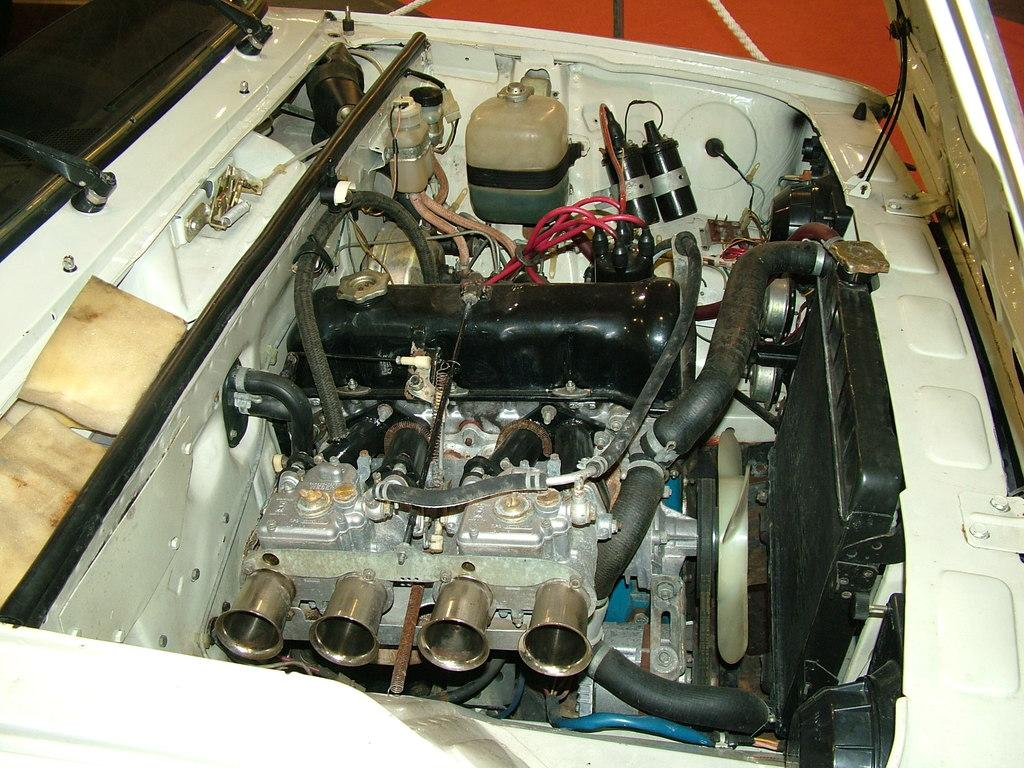What is the main subject of the image? The main subject of the image is an engine. What other objects can be seen in the image? There are wires and pipes in the image. Can you describe the white object in the image? There is a white object in the image, but its specific details are not mentioned in the provided facts. What word is being whispered by the zephyr in the image? There is no mention of a zephyr or any whispered words in the image. 